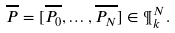<formula> <loc_0><loc_0><loc_500><loc_500>\overline { P } = [ \overline { P _ { 0 } } , \dots , \overline { P _ { N } } ] \in \P ^ { N } _ { k } .</formula> 